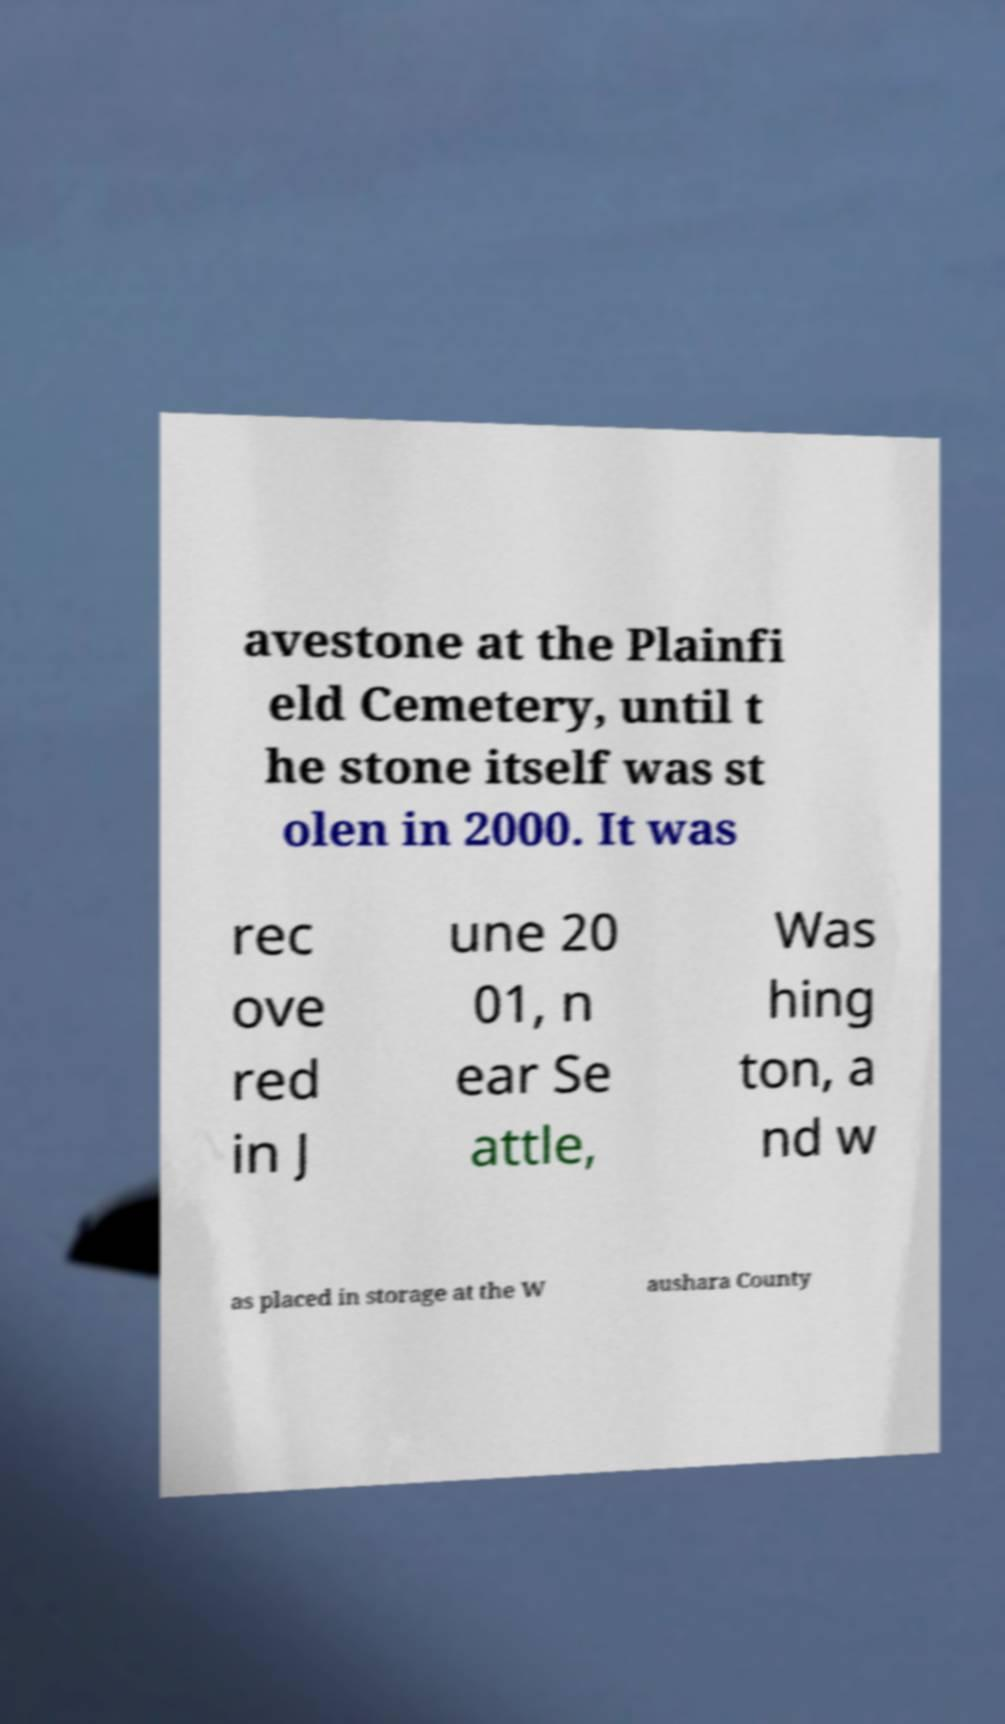There's text embedded in this image that I need extracted. Can you transcribe it verbatim? avestone at the Plainfi eld Cemetery, until t he stone itself was st olen in 2000. It was rec ove red in J une 20 01, n ear Se attle, Was hing ton, a nd w as placed in storage at the W aushara County 